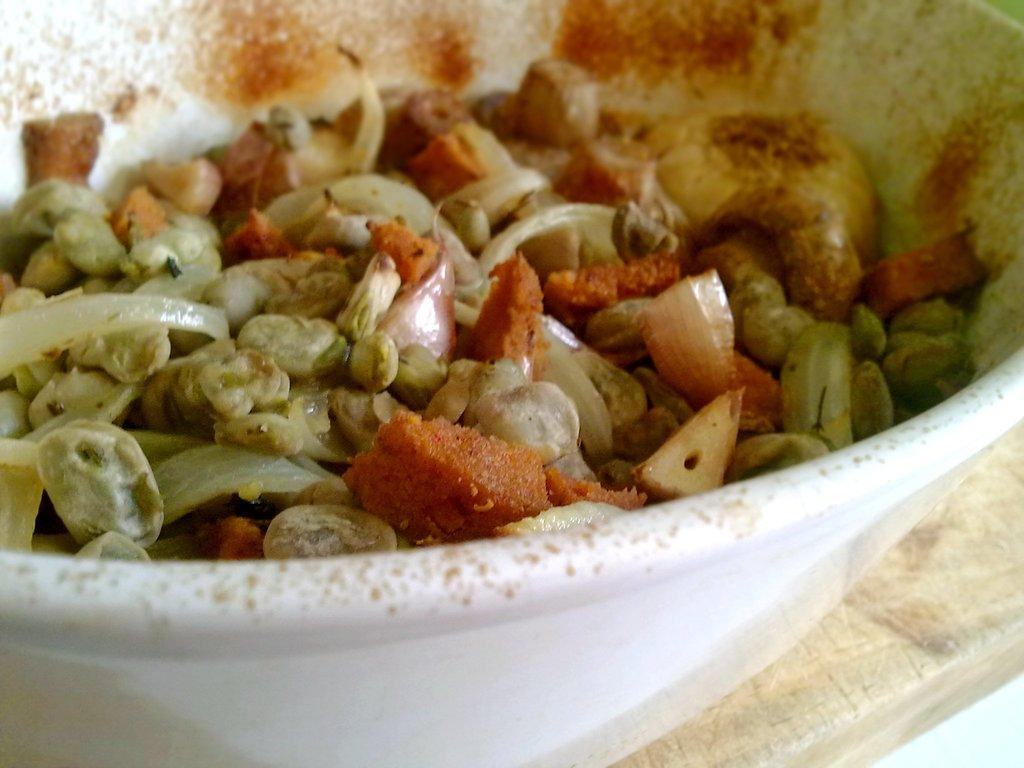What is in the bowl that is visible in the image? The bowl contains food. Where is the bowl located in the image? The bowl is placed on a table. What might be the type of food in the bowl? The specific type of food in the bowl cannot be determined from the image. Can you see a cat enjoying the food in the bowl in the image? There is no cat present in the image, and the image does not depict any pleasure or enjoyment related to the food in the bowl. 